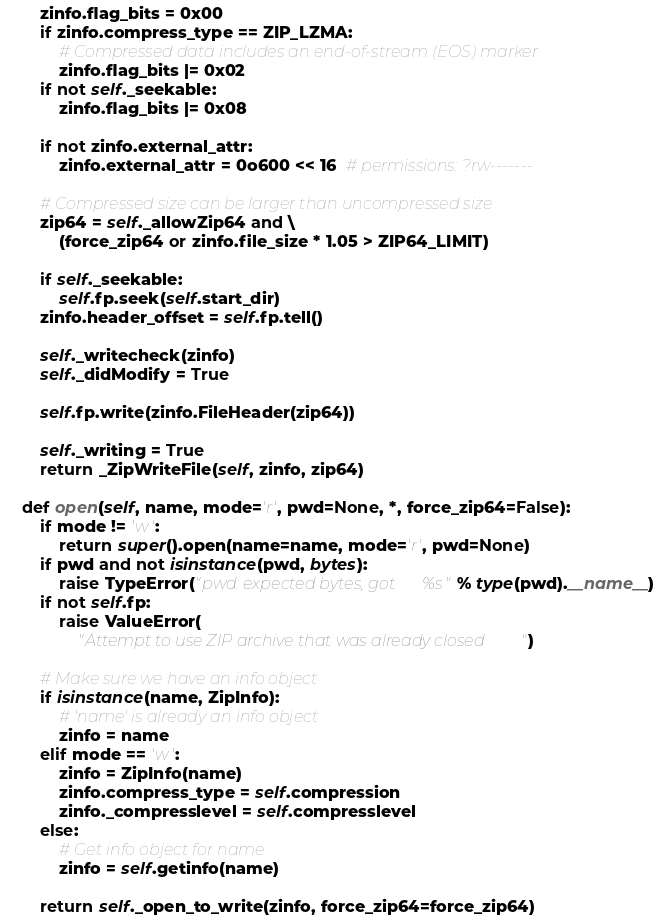Convert code to text. <code><loc_0><loc_0><loc_500><loc_500><_Python_>
        zinfo.flag_bits = 0x00
        if zinfo.compress_type == ZIP_LZMA:
            # Compressed data includes an end-of-stream (EOS) marker
            zinfo.flag_bits |= 0x02
        if not self._seekable:
            zinfo.flag_bits |= 0x08

        if not zinfo.external_attr:
            zinfo.external_attr = 0o600 << 16  # permissions: ?rw-------

        # Compressed size can be larger than uncompressed size
        zip64 = self._allowZip64 and \
            (force_zip64 or zinfo.file_size * 1.05 > ZIP64_LIMIT)

        if self._seekable:
            self.fp.seek(self.start_dir)
        zinfo.header_offset = self.fp.tell()

        self._writecheck(zinfo)
        self._didModify = True

        self.fp.write(zinfo.FileHeader(zip64))

        self._writing = True
        return _ZipWriteFile(self, zinfo, zip64)

    def open(self, name, mode='r', pwd=None, *, force_zip64=False):
        if mode != 'w':
            return super().open(name=name, mode='r', pwd=None)
        if pwd and not isinstance(pwd, bytes):
            raise TypeError("pwd: expected bytes, got %s" % type(pwd).__name__)
        if not self.fp:
            raise ValueError(
                "Attempt to use ZIP archive that was already closed")

        # Make sure we have an info object
        if isinstance(name, ZipInfo):
            # 'name' is already an info object
            zinfo = name
        elif mode == 'w':
            zinfo = ZipInfo(name)
            zinfo.compress_type = self.compression
            zinfo._compresslevel = self.compresslevel
        else:
            # Get info object for name
            zinfo = self.getinfo(name)

        return self._open_to_write(zinfo, force_zip64=force_zip64)
</code> 